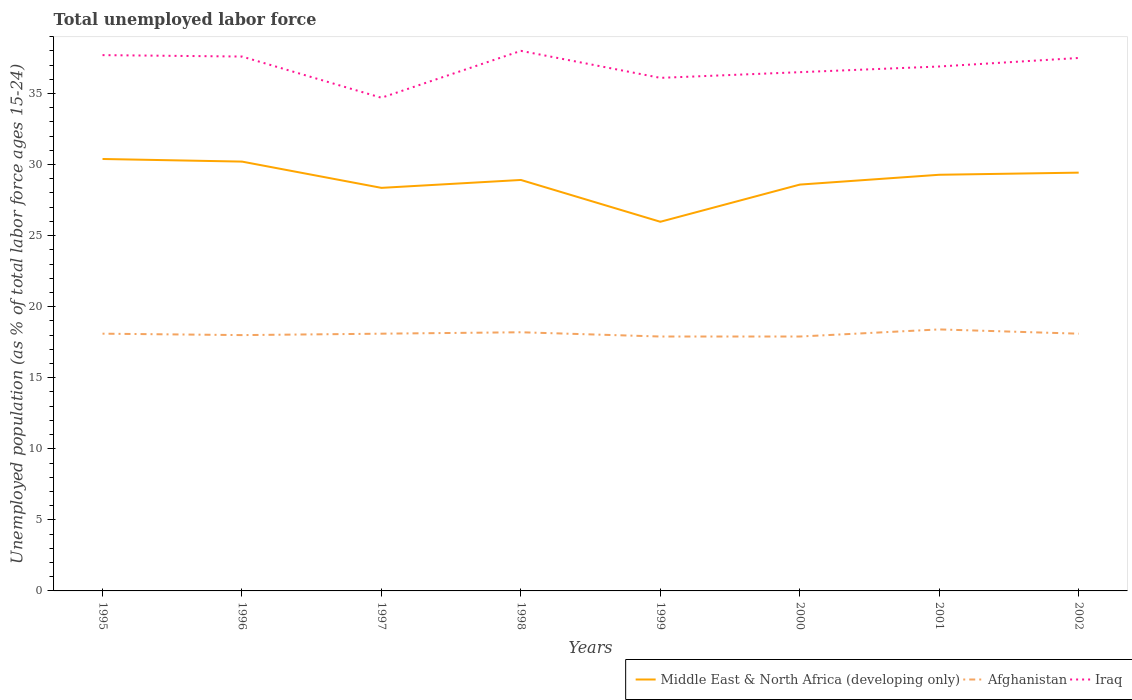Does the line corresponding to Afghanistan intersect with the line corresponding to Middle East & North Africa (developing only)?
Keep it short and to the point. No. Across all years, what is the maximum percentage of unemployed population in in Middle East & North Africa (developing only)?
Make the answer very short. 25.97. In which year was the percentage of unemployed population in in Middle East & North Africa (developing only) maximum?
Keep it short and to the point. 1999. What is the total percentage of unemployed population in in Afghanistan in the graph?
Your answer should be compact. -0.2. What is the difference between the highest and the second highest percentage of unemployed population in in Iraq?
Make the answer very short. 3.3. What is the difference between two consecutive major ticks on the Y-axis?
Ensure brevity in your answer.  5. Are the values on the major ticks of Y-axis written in scientific E-notation?
Your response must be concise. No. Does the graph contain grids?
Make the answer very short. No. Where does the legend appear in the graph?
Your answer should be compact. Bottom right. How many legend labels are there?
Give a very brief answer. 3. How are the legend labels stacked?
Your answer should be very brief. Horizontal. What is the title of the graph?
Provide a short and direct response. Total unemployed labor force. Does "Benin" appear as one of the legend labels in the graph?
Your answer should be very brief. No. What is the label or title of the X-axis?
Your answer should be very brief. Years. What is the label or title of the Y-axis?
Give a very brief answer. Unemployed population (as % of total labor force ages 15-24). What is the Unemployed population (as % of total labor force ages 15-24) of Middle East & North Africa (developing only) in 1995?
Your answer should be compact. 30.39. What is the Unemployed population (as % of total labor force ages 15-24) of Afghanistan in 1995?
Ensure brevity in your answer.  18.1. What is the Unemployed population (as % of total labor force ages 15-24) in Iraq in 1995?
Ensure brevity in your answer.  37.7. What is the Unemployed population (as % of total labor force ages 15-24) of Middle East & North Africa (developing only) in 1996?
Your response must be concise. 30.21. What is the Unemployed population (as % of total labor force ages 15-24) in Afghanistan in 1996?
Provide a succinct answer. 18. What is the Unemployed population (as % of total labor force ages 15-24) of Iraq in 1996?
Keep it short and to the point. 37.6. What is the Unemployed population (as % of total labor force ages 15-24) of Middle East & North Africa (developing only) in 1997?
Your answer should be compact. 28.36. What is the Unemployed population (as % of total labor force ages 15-24) in Afghanistan in 1997?
Your response must be concise. 18.1. What is the Unemployed population (as % of total labor force ages 15-24) in Iraq in 1997?
Offer a very short reply. 34.7. What is the Unemployed population (as % of total labor force ages 15-24) in Middle East & North Africa (developing only) in 1998?
Offer a very short reply. 28.92. What is the Unemployed population (as % of total labor force ages 15-24) of Afghanistan in 1998?
Your answer should be very brief. 18.2. What is the Unemployed population (as % of total labor force ages 15-24) in Middle East & North Africa (developing only) in 1999?
Provide a succinct answer. 25.97. What is the Unemployed population (as % of total labor force ages 15-24) of Afghanistan in 1999?
Keep it short and to the point. 17.9. What is the Unemployed population (as % of total labor force ages 15-24) of Iraq in 1999?
Give a very brief answer. 36.1. What is the Unemployed population (as % of total labor force ages 15-24) of Middle East & North Africa (developing only) in 2000?
Make the answer very short. 28.59. What is the Unemployed population (as % of total labor force ages 15-24) of Afghanistan in 2000?
Your response must be concise. 17.9. What is the Unemployed population (as % of total labor force ages 15-24) of Iraq in 2000?
Provide a succinct answer. 36.5. What is the Unemployed population (as % of total labor force ages 15-24) of Middle East & North Africa (developing only) in 2001?
Ensure brevity in your answer.  29.28. What is the Unemployed population (as % of total labor force ages 15-24) of Afghanistan in 2001?
Offer a very short reply. 18.4. What is the Unemployed population (as % of total labor force ages 15-24) of Iraq in 2001?
Your response must be concise. 36.9. What is the Unemployed population (as % of total labor force ages 15-24) in Middle East & North Africa (developing only) in 2002?
Offer a very short reply. 29.43. What is the Unemployed population (as % of total labor force ages 15-24) of Afghanistan in 2002?
Give a very brief answer. 18.1. What is the Unemployed population (as % of total labor force ages 15-24) in Iraq in 2002?
Your answer should be very brief. 37.5. Across all years, what is the maximum Unemployed population (as % of total labor force ages 15-24) of Middle East & North Africa (developing only)?
Provide a succinct answer. 30.39. Across all years, what is the maximum Unemployed population (as % of total labor force ages 15-24) of Afghanistan?
Make the answer very short. 18.4. Across all years, what is the minimum Unemployed population (as % of total labor force ages 15-24) in Middle East & North Africa (developing only)?
Keep it short and to the point. 25.97. Across all years, what is the minimum Unemployed population (as % of total labor force ages 15-24) of Afghanistan?
Offer a terse response. 17.9. Across all years, what is the minimum Unemployed population (as % of total labor force ages 15-24) of Iraq?
Provide a succinct answer. 34.7. What is the total Unemployed population (as % of total labor force ages 15-24) of Middle East & North Africa (developing only) in the graph?
Ensure brevity in your answer.  231.15. What is the total Unemployed population (as % of total labor force ages 15-24) of Afghanistan in the graph?
Ensure brevity in your answer.  144.7. What is the total Unemployed population (as % of total labor force ages 15-24) in Iraq in the graph?
Make the answer very short. 295. What is the difference between the Unemployed population (as % of total labor force ages 15-24) of Middle East & North Africa (developing only) in 1995 and that in 1996?
Your answer should be compact. 0.18. What is the difference between the Unemployed population (as % of total labor force ages 15-24) of Iraq in 1995 and that in 1996?
Ensure brevity in your answer.  0.1. What is the difference between the Unemployed population (as % of total labor force ages 15-24) in Middle East & North Africa (developing only) in 1995 and that in 1997?
Provide a short and direct response. 2.03. What is the difference between the Unemployed population (as % of total labor force ages 15-24) in Afghanistan in 1995 and that in 1997?
Keep it short and to the point. 0. What is the difference between the Unemployed population (as % of total labor force ages 15-24) in Iraq in 1995 and that in 1997?
Offer a terse response. 3. What is the difference between the Unemployed population (as % of total labor force ages 15-24) in Middle East & North Africa (developing only) in 1995 and that in 1998?
Ensure brevity in your answer.  1.48. What is the difference between the Unemployed population (as % of total labor force ages 15-24) of Middle East & North Africa (developing only) in 1995 and that in 1999?
Offer a terse response. 4.42. What is the difference between the Unemployed population (as % of total labor force ages 15-24) of Iraq in 1995 and that in 1999?
Your answer should be very brief. 1.6. What is the difference between the Unemployed population (as % of total labor force ages 15-24) in Middle East & North Africa (developing only) in 1995 and that in 2000?
Your answer should be compact. 1.8. What is the difference between the Unemployed population (as % of total labor force ages 15-24) of Middle East & North Africa (developing only) in 1995 and that in 2001?
Keep it short and to the point. 1.11. What is the difference between the Unemployed population (as % of total labor force ages 15-24) of Middle East & North Africa (developing only) in 1995 and that in 2002?
Ensure brevity in your answer.  0.96. What is the difference between the Unemployed population (as % of total labor force ages 15-24) in Afghanistan in 1995 and that in 2002?
Provide a short and direct response. 0. What is the difference between the Unemployed population (as % of total labor force ages 15-24) in Iraq in 1995 and that in 2002?
Provide a short and direct response. 0.2. What is the difference between the Unemployed population (as % of total labor force ages 15-24) of Middle East & North Africa (developing only) in 1996 and that in 1997?
Your answer should be very brief. 1.85. What is the difference between the Unemployed population (as % of total labor force ages 15-24) of Iraq in 1996 and that in 1997?
Give a very brief answer. 2.9. What is the difference between the Unemployed population (as % of total labor force ages 15-24) in Middle East & North Africa (developing only) in 1996 and that in 1998?
Ensure brevity in your answer.  1.29. What is the difference between the Unemployed population (as % of total labor force ages 15-24) of Afghanistan in 1996 and that in 1998?
Offer a very short reply. -0.2. What is the difference between the Unemployed population (as % of total labor force ages 15-24) in Middle East & North Africa (developing only) in 1996 and that in 1999?
Offer a terse response. 4.23. What is the difference between the Unemployed population (as % of total labor force ages 15-24) in Afghanistan in 1996 and that in 1999?
Provide a short and direct response. 0.1. What is the difference between the Unemployed population (as % of total labor force ages 15-24) of Iraq in 1996 and that in 1999?
Offer a terse response. 1.5. What is the difference between the Unemployed population (as % of total labor force ages 15-24) in Middle East & North Africa (developing only) in 1996 and that in 2000?
Provide a succinct answer. 1.62. What is the difference between the Unemployed population (as % of total labor force ages 15-24) of Afghanistan in 1996 and that in 2000?
Keep it short and to the point. 0.1. What is the difference between the Unemployed population (as % of total labor force ages 15-24) in Iraq in 1996 and that in 2000?
Provide a succinct answer. 1.1. What is the difference between the Unemployed population (as % of total labor force ages 15-24) in Middle East & North Africa (developing only) in 1996 and that in 2001?
Make the answer very short. 0.93. What is the difference between the Unemployed population (as % of total labor force ages 15-24) in Afghanistan in 1996 and that in 2001?
Your answer should be compact. -0.4. What is the difference between the Unemployed population (as % of total labor force ages 15-24) of Iraq in 1996 and that in 2001?
Your response must be concise. 0.7. What is the difference between the Unemployed population (as % of total labor force ages 15-24) in Middle East & North Africa (developing only) in 1996 and that in 2002?
Your response must be concise. 0.78. What is the difference between the Unemployed population (as % of total labor force ages 15-24) of Iraq in 1996 and that in 2002?
Provide a short and direct response. 0.1. What is the difference between the Unemployed population (as % of total labor force ages 15-24) of Middle East & North Africa (developing only) in 1997 and that in 1998?
Your answer should be very brief. -0.56. What is the difference between the Unemployed population (as % of total labor force ages 15-24) in Afghanistan in 1997 and that in 1998?
Offer a very short reply. -0.1. What is the difference between the Unemployed population (as % of total labor force ages 15-24) in Middle East & North Africa (developing only) in 1997 and that in 1999?
Keep it short and to the point. 2.39. What is the difference between the Unemployed population (as % of total labor force ages 15-24) of Iraq in 1997 and that in 1999?
Your answer should be compact. -1.4. What is the difference between the Unemployed population (as % of total labor force ages 15-24) in Middle East & North Africa (developing only) in 1997 and that in 2000?
Your answer should be compact. -0.23. What is the difference between the Unemployed population (as % of total labor force ages 15-24) of Afghanistan in 1997 and that in 2000?
Give a very brief answer. 0.2. What is the difference between the Unemployed population (as % of total labor force ages 15-24) of Iraq in 1997 and that in 2000?
Your answer should be compact. -1.8. What is the difference between the Unemployed population (as % of total labor force ages 15-24) of Middle East & North Africa (developing only) in 1997 and that in 2001?
Your answer should be very brief. -0.92. What is the difference between the Unemployed population (as % of total labor force ages 15-24) of Iraq in 1997 and that in 2001?
Give a very brief answer. -2.2. What is the difference between the Unemployed population (as % of total labor force ages 15-24) in Middle East & North Africa (developing only) in 1997 and that in 2002?
Your response must be concise. -1.07. What is the difference between the Unemployed population (as % of total labor force ages 15-24) in Afghanistan in 1997 and that in 2002?
Provide a short and direct response. 0. What is the difference between the Unemployed population (as % of total labor force ages 15-24) in Iraq in 1997 and that in 2002?
Make the answer very short. -2.8. What is the difference between the Unemployed population (as % of total labor force ages 15-24) in Middle East & North Africa (developing only) in 1998 and that in 1999?
Your response must be concise. 2.94. What is the difference between the Unemployed population (as % of total labor force ages 15-24) of Afghanistan in 1998 and that in 1999?
Your answer should be very brief. 0.3. What is the difference between the Unemployed population (as % of total labor force ages 15-24) in Middle East & North Africa (developing only) in 1998 and that in 2000?
Provide a succinct answer. 0.33. What is the difference between the Unemployed population (as % of total labor force ages 15-24) in Afghanistan in 1998 and that in 2000?
Your answer should be compact. 0.3. What is the difference between the Unemployed population (as % of total labor force ages 15-24) of Iraq in 1998 and that in 2000?
Offer a very short reply. 1.5. What is the difference between the Unemployed population (as % of total labor force ages 15-24) of Middle East & North Africa (developing only) in 1998 and that in 2001?
Your answer should be compact. -0.37. What is the difference between the Unemployed population (as % of total labor force ages 15-24) of Afghanistan in 1998 and that in 2001?
Your answer should be very brief. -0.2. What is the difference between the Unemployed population (as % of total labor force ages 15-24) of Iraq in 1998 and that in 2001?
Offer a terse response. 1.1. What is the difference between the Unemployed population (as % of total labor force ages 15-24) of Middle East & North Africa (developing only) in 1998 and that in 2002?
Offer a very short reply. -0.51. What is the difference between the Unemployed population (as % of total labor force ages 15-24) of Iraq in 1998 and that in 2002?
Keep it short and to the point. 0.5. What is the difference between the Unemployed population (as % of total labor force ages 15-24) in Middle East & North Africa (developing only) in 1999 and that in 2000?
Provide a short and direct response. -2.62. What is the difference between the Unemployed population (as % of total labor force ages 15-24) in Middle East & North Africa (developing only) in 1999 and that in 2001?
Ensure brevity in your answer.  -3.31. What is the difference between the Unemployed population (as % of total labor force ages 15-24) of Afghanistan in 1999 and that in 2001?
Ensure brevity in your answer.  -0.5. What is the difference between the Unemployed population (as % of total labor force ages 15-24) in Middle East & North Africa (developing only) in 1999 and that in 2002?
Your answer should be compact. -3.46. What is the difference between the Unemployed population (as % of total labor force ages 15-24) of Afghanistan in 1999 and that in 2002?
Give a very brief answer. -0.2. What is the difference between the Unemployed population (as % of total labor force ages 15-24) in Middle East & North Africa (developing only) in 2000 and that in 2001?
Offer a very short reply. -0.69. What is the difference between the Unemployed population (as % of total labor force ages 15-24) in Afghanistan in 2000 and that in 2001?
Your response must be concise. -0.5. What is the difference between the Unemployed population (as % of total labor force ages 15-24) in Iraq in 2000 and that in 2001?
Your response must be concise. -0.4. What is the difference between the Unemployed population (as % of total labor force ages 15-24) in Middle East & North Africa (developing only) in 2000 and that in 2002?
Ensure brevity in your answer.  -0.84. What is the difference between the Unemployed population (as % of total labor force ages 15-24) of Iraq in 2000 and that in 2002?
Provide a short and direct response. -1. What is the difference between the Unemployed population (as % of total labor force ages 15-24) of Middle East & North Africa (developing only) in 2001 and that in 2002?
Offer a terse response. -0.15. What is the difference between the Unemployed population (as % of total labor force ages 15-24) of Middle East & North Africa (developing only) in 1995 and the Unemployed population (as % of total labor force ages 15-24) of Afghanistan in 1996?
Provide a succinct answer. 12.39. What is the difference between the Unemployed population (as % of total labor force ages 15-24) of Middle East & North Africa (developing only) in 1995 and the Unemployed population (as % of total labor force ages 15-24) of Iraq in 1996?
Your answer should be compact. -7.21. What is the difference between the Unemployed population (as % of total labor force ages 15-24) of Afghanistan in 1995 and the Unemployed population (as % of total labor force ages 15-24) of Iraq in 1996?
Make the answer very short. -19.5. What is the difference between the Unemployed population (as % of total labor force ages 15-24) of Middle East & North Africa (developing only) in 1995 and the Unemployed population (as % of total labor force ages 15-24) of Afghanistan in 1997?
Ensure brevity in your answer.  12.29. What is the difference between the Unemployed population (as % of total labor force ages 15-24) in Middle East & North Africa (developing only) in 1995 and the Unemployed population (as % of total labor force ages 15-24) in Iraq in 1997?
Give a very brief answer. -4.31. What is the difference between the Unemployed population (as % of total labor force ages 15-24) of Afghanistan in 1995 and the Unemployed population (as % of total labor force ages 15-24) of Iraq in 1997?
Make the answer very short. -16.6. What is the difference between the Unemployed population (as % of total labor force ages 15-24) of Middle East & North Africa (developing only) in 1995 and the Unemployed population (as % of total labor force ages 15-24) of Afghanistan in 1998?
Offer a very short reply. 12.19. What is the difference between the Unemployed population (as % of total labor force ages 15-24) of Middle East & North Africa (developing only) in 1995 and the Unemployed population (as % of total labor force ages 15-24) of Iraq in 1998?
Give a very brief answer. -7.61. What is the difference between the Unemployed population (as % of total labor force ages 15-24) of Afghanistan in 1995 and the Unemployed population (as % of total labor force ages 15-24) of Iraq in 1998?
Give a very brief answer. -19.9. What is the difference between the Unemployed population (as % of total labor force ages 15-24) of Middle East & North Africa (developing only) in 1995 and the Unemployed population (as % of total labor force ages 15-24) of Afghanistan in 1999?
Provide a short and direct response. 12.49. What is the difference between the Unemployed population (as % of total labor force ages 15-24) of Middle East & North Africa (developing only) in 1995 and the Unemployed population (as % of total labor force ages 15-24) of Iraq in 1999?
Give a very brief answer. -5.71. What is the difference between the Unemployed population (as % of total labor force ages 15-24) of Afghanistan in 1995 and the Unemployed population (as % of total labor force ages 15-24) of Iraq in 1999?
Provide a succinct answer. -18. What is the difference between the Unemployed population (as % of total labor force ages 15-24) of Middle East & North Africa (developing only) in 1995 and the Unemployed population (as % of total labor force ages 15-24) of Afghanistan in 2000?
Keep it short and to the point. 12.49. What is the difference between the Unemployed population (as % of total labor force ages 15-24) of Middle East & North Africa (developing only) in 1995 and the Unemployed population (as % of total labor force ages 15-24) of Iraq in 2000?
Your answer should be compact. -6.11. What is the difference between the Unemployed population (as % of total labor force ages 15-24) in Afghanistan in 1995 and the Unemployed population (as % of total labor force ages 15-24) in Iraq in 2000?
Ensure brevity in your answer.  -18.4. What is the difference between the Unemployed population (as % of total labor force ages 15-24) in Middle East & North Africa (developing only) in 1995 and the Unemployed population (as % of total labor force ages 15-24) in Afghanistan in 2001?
Keep it short and to the point. 11.99. What is the difference between the Unemployed population (as % of total labor force ages 15-24) of Middle East & North Africa (developing only) in 1995 and the Unemployed population (as % of total labor force ages 15-24) of Iraq in 2001?
Make the answer very short. -6.51. What is the difference between the Unemployed population (as % of total labor force ages 15-24) in Afghanistan in 1995 and the Unemployed population (as % of total labor force ages 15-24) in Iraq in 2001?
Keep it short and to the point. -18.8. What is the difference between the Unemployed population (as % of total labor force ages 15-24) in Middle East & North Africa (developing only) in 1995 and the Unemployed population (as % of total labor force ages 15-24) in Afghanistan in 2002?
Give a very brief answer. 12.29. What is the difference between the Unemployed population (as % of total labor force ages 15-24) in Middle East & North Africa (developing only) in 1995 and the Unemployed population (as % of total labor force ages 15-24) in Iraq in 2002?
Give a very brief answer. -7.11. What is the difference between the Unemployed population (as % of total labor force ages 15-24) of Afghanistan in 1995 and the Unemployed population (as % of total labor force ages 15-24) of Iraq in 2002?
Offer a very short reply. -19.4. What is the difference between the Unemployed population (as % of total labor force ages 15-24) in Middle East & North Africa (developing only) in 1996 and the Unemployed population (as % of total labor force ages 15-24) in Afghanistan in 1997?
Keep it short and to the point. 12.11. What is the difference between the Unemployed population (as % of total labor force ages 15-24) of Middle East & North Africa (developing only) in 1996 and the Unemployed population (as % of total labor force ages 15-24) of Iraq in 1997?
Your answer should be very brief. -4.49. What is the difference between the Unemployed population (as % of total labor force ages 15-24) of Afghanistan in 1996 and the Unemployed population (as % of total labor force ages 15-24) of Iraq in 1997?
Provide a short and direct response. -16.7. What is the difference between the Unemployed population (as % of total labor force ages 15-24) of Middle East & North Africa (developing only) in 1996 and the Unemployed population (as % of total labor force ages 15-24) of Afghanistan in 1998?
Your response must be concise. 12.01. What is the difference between the Unemployed population (as % of total labor force ages 15-24) in Middle East & North Africa (developing only) in 1996 and the Unemployed population (as % of total labor force ages 15-24) in Iraq in 1998?
Ensure brevity in your answer.  -7.79. What is the difference between the Unemployed population (as % of total labor force ages 15-24) in Afghanistan in 1996 and the Unemployed population (as % of total labor force ages 15-24) in Iraq in 1998?
Make the answer very short. -20. What is the difference between the Unemployed population (as % of total labor force ages 15-24) of Middle East & North Africa (developing only) in 1996 and the Unemployed population (as % of total labor force ages 15-24) of Afghanistan in 1999?
Offer a terse response. 12.31. What is the difference between the Unemployed population (as % of total labor force ages 15-24) in Middle East & North Africa (developing only) in 1996 and the Unemployed population (as % of total labor force ages 15-24) in Iraq in 1999?
Ensure brevity in your answer.  -5.89. What is the difference between the Unemployed population (as % of total labor force ages 15-24) in Afghanistan in 1996 and the Unemployed population (as % of total labor force ages 15-24) in Iraq in 1999?
Keep it short and to the point. -18.1. What is the difference between the Unemployed population (as % of total labor force ages 15-24) of Middle East & North Africa (developing only) in 1996 and the Unemployed population (as % of total labor force ages 15-24) of Afghanistan in 2000?
Keep it short and to the point. 12.31. What is the difference between the Unemployed population (as % of total labor force ages 15-24) of Middle East & North Africa (developing only) in 1996 and the Unemployed population (as % of total labor force ages 15-24) of Iraq in 2000?
Make the answer very short. -6.29. What is the difference between the Unemployed population (as % of total labor force ages 15-24) of Afghanistan in 1996 and the Unemployed population (as % of total labor force ages 15-24) of Iraq in 2000?
Your answer should be very brief. -18.5. What is the difference between the Unemployed population (as % of total labor force ages 15-24) of Middle East & North Africa (developing only) in 1996 and the Unemployed population (as % of total labor force ages 15-24) of Afghanistan in 2001?
Provide a succinct answer. 11.81. What is the difference between the Unemployed population (as % of total labor force ages 15-24) of Middle East & North Africa (developing only) in 1996 and the Unemployed population (as % of total labor force ages 15-24) of Iraq in 2001?
Ensure brevity in your answer.  -6.69. What is the difference between the Unemployed population (as % of total labor force ages 15-24) of Afghanistan in 1996 and the Unemployed population (as % of total labor force ages 15-24) of Iraq in 2001?
Your response must be concise. -18.9. What is the difference between the Unemployed population (as % of total labor force ages 15-24) of Middle East & North Africa (developing only) in 1996 and the Unemployed population (as % of total labor force ages 15-24) of Afghanistan in 2002?
Offer a terse response. 12.11. What is the difference between the Unemployed population (as % of total labor force ages 15-24) in Middle East & North Africa (developing only) in 1996 and the Unemployed population (as % of total labor force ages 15-24) in Iraq in 2002?
Provide a short and direct response. -7.29. What is the difference between the Unemployed population (as % of total labor force ages 15-24) in Afghanistan in 1996 and the Unemployed population (as % of total labor force ages 15-24) in Iraq in 2002?
Make the answer very short. -19.5. What is the difference between the Unemployed population (as % of total labor force ages 15-24) of Middle East & North Africa (developing only) in 1997 and the Unemployed population (as % of total labor force ages 15-24) of Afghanistan in 1998?
Offer a terse response. 10.16. What is the difference between the Unemployed population (as % of total labor force ages 15-24) in Middle East & North Africa (developing only) in 1997 and the Unemployed population (as % of total labor force ages 15-24) in Iraq in 1998?
Your response must be concise. -9.64. What is the difference between the Unemployed population (as % of total labor force ages 15-24) of Afghanistan in 1997 and the Unemployed population (as % of total labor force ages 15-24) of Iraq in 1998?
Offer a very short reply. -19.9. What is the difference between the Unemployed population (as % of total labor force ages 15-24) of Middle East & North Africa (developing only) in 1997 and the Unemployed population (as % of total labor force ages 15-24) of Afghanistan in 1999?
Your answer should be very brief. 10.46. What is the difference between the Unemployed population (as % of total labor force ages 15-24) in Middle East & North Africa (developing only) in 1997 and the Unemployed population (as % of total labor force ages 15-24) in Iraq in 1999?
Provide a succinct answer. -7.74. What is the difference between the Unemployed population (as % of total labor force ages 15-24) in Middle East & North Africa (developing only) in 1997 and the Unemployed population (as % of total labor force ages 15-24) in Afghanistan in 2000?
Your answer should be very brief. 10.46. What is the difference between the Unemployed population (as % of total labor force ages 15-24) of Middle East & North Africa (developing only) in 1997 and the Unemployed population (as % of total labor force ages 15-24) of Iraq in 2000?
Provide a short and direct response. -8.14. What is the difference between the Unemployed population (as % of total labor force ages 15-24) of Afghanistan in 1997 and the Unemployed population (as % of total labor force ages 15-24) of Iraq in 2000?
Keep it short and to the point. -18.4. What is the difference between the Unemployed population (as % of total labor force ages 15-24) in Middle East & North Africa (developing only) in 1997 and the Unemployed population (as % of total labor force ages 15-24) in Afghanistan in 2001?
Ensure brevity in your answer.  9.96. What is the difference between the Unemployed population (as % of total labor force ages 15-24) of Middle East & North Africa (developing only) in 1997 and the Unemployed population (as % of total labor force ages 15-24) of Iraq in 2001?
Give a very brief answer. -8.54. What is the difference between the Unemployed population (as % of total labor force ages 15-24) of Afghanistan in 1997 and the Unemployed population (as % of total labor force ages 15-24) of Iraq in 2001?
Give a very brief answer. -18.8. What is the difference between the Unemployed population (as % of total labor force ages 15-24) in Middle East & North Africa (developing only) in 1997 and the Unemployed population (as % of total labor force ages 15-24) in Afghanistan in 2002?
Offer a terse response. 10.26. What is the difference between the Unemployed population (as % of total labor force ages 15-24) in Middle East & North Africa (developing only) in 1997 and the Unemployed population (as % of total labor force ages 15-24) in Iraq in 2002?
Ensure brevity in your answer.  -9.14. What is the difference between the Unemployed population (as % of total labor force ages 15-24) in Afghanistan in 1997 and the Unemployed population (as % of total labor force ages 15-24) in Iraq in 2002?
Offer a very short reply. -19.4. What is the difference between the Unemployed population (as % of total labor force ages 15-24) of Middle East & North Africa (developing only) in 1998 and the Unemployed population (as % of total labor force ages 15-24) of Afghanistan in 1999?
Provide a succinct answer. 11.02. What is the difference between the Unemployed population (as % of total labor force ages 15-24) in Middle East & North Africa (developing only) in 1998 and the Unemployed population (as % of total labor force ages 15-24) in Iraq in 1999?
Offer a very short reply. -7.18. What is the difference between the Unemployed population (as % of total labor force ages 15-24) in Afghanistan in 1998 and the Unemployed population (as % of total labor force ages 15-24) in Iraq in 1999?
Offer a very short reply. -17.9. What is the difference between the Unemployed population (as % of total labor force ages 15-24) of Middle East & North Africa (developing only) in 1998 and the Unemployed population (as % of total labor force ages 15-24) of Afghanistan in 2000?
Provide a short and direct response. 11.02. What is the difference between the Unemployed population (as % of total labor force ages 15-24) in Middle East & North Africa (developing only) in 1998 and the Unemployed population (as % of total labor force ages 15-24) in Iraq in 2000?
Keep it short and to the point. -7.58. What is the difference between the Unemployed population (as % of total labor force ages 15-24) of Afghanistan in 1998 and the Unemployed population (as % of total labor force ages 15-24) of Iraq in 2000?
Keep it short and to the point. -18.3. What is the difference between the Unemployed population (as % of total labor force ages 15-24) in Middle East & North Africa (developing only) in 1998 and the Unemployed population (as % of total labor force ages 15-24) in Afghanistan in 2001?
Provide a short and direct response. 10.52. What is the difference between the Unemployed population (as % of total labor force ages 15-24) in Middle East & North Africa (developing only) in 1998 and the Unemployed population (as % of total labor force ages 15-24) in Iraq in 2001?
Keep it short and to the point. -7.98. What is the difference between the Unemployed population (as % of total labor force ages 15-24) in Afghanistan in 1998 and the Unemployed population (as % of total labor force ages 15-24) in Iraq in 2001?
Offer a terse response. -18.7. What is the difference between the Unemployed population (as % of total labor force ages 15-24) in Middle East & North Africa (developing only) in 1998 and the Unemployed population (as % of total labor force ages 15-24) in Afghanistan in 2002?
Offer a very short reply. 10.82. What is the difference between the Unemployed population (as % of total labor force ages 15-24) in Middle East & North Africa (developing only) in 1998 and the Unemployed population (as % of total labor force ages 15-24) in Iraq in 2002?
Give a very brief answer. -8.58. What is the difference between the Unemployed population (as % of total labor force ages 15-24) of Afghanistan in 1998 and the Unemployed population (as % of total labor force ages 15-24) of Iraq in 2002?
Provide a short and direct response. -19.3. What is the difference between the Unemployed population (as % of total labor force ages 15-24) in Middle East & North Africa (developing only) in 1999 and the Unemployed population (as % of total labor force ages 15-24) in Afghanistan in 2000?
Keep it short and to the point. 8.07. What is the difference between the Unemployed population (as % of total labor force ages 15-24) of Middle East & North Africa (developing only) in 1999 and the Unemployed population (as % of total labor force ages 15-24) of Iraq in 2000?
Offer a terse response. -10.53. What is the difference between the Unemployed population (as % of total labor force ages 15-24) of Afghanistan in 1999 and the Unemployed population (as % of total labor force ages 15-24) of Iraq in 2000?
Ensure brevity in your answer.  -18.6. What is the difference between the Unemployed population (as % of total labor force ages 15-24) of Middle East & North Africa (developing only) in 1999 and the Unemployed population (as % of total labor force ages 15-24) of Afghanistan in 2001?
Give a very brief answer. 7.57. What is the difference between the Unemployed population (as % of total labor force ages 15-24) in Middle East & North Africa (developing only) in 1999 and the Unemployed population (as % of total labor force ages 15-24) in Iraq in 2001?
Provide a succinct answer. -10.93. What is the difference between the Unemployed population (as % of total labor force ages 15-24) of Afghanistan in 1999 and the Unemployed population (as % of total labor force ages 15-24) of Iraq in 2001?
Make the answer very short. -19. What is the difference between the Unemployed population (as % of total labor force ages 15-24) of Middle East & North Africa (developing only) in 1999 and the Unemployed population (as % of total labor force ages 15-24) of Afghanistan in 2002?
Keep it short and to the point. 7.87. What is the difference between the Unemployed population (as % of total labor force ages 15-24) of Middle East & North Africa (developing only) in 1999 and the Unemployed population (as % of total labor force ages 15-24) of Iraq in 2002?
Give a very brief answer. -11.53. What is the difference between the Unemployed population (as % of total labor force ages 15-24) of Afghanistan in 1999 and the Unemployed population (as % of total labor force ages 15-24) of Iraq in 2002?
Your response must be concise. -19.6. What is the difference between the Unemployed population (as % of total labor force ages 15-24) of Middle East & North Africa (developing only) in 2000 and the Unemployed population (as % of total labor force ages 15-24) of Afghanistan in 2001?
Your answer should be very brief. 10.19. What is the difference between the Unemployed population (as % of total labor force ages 15-24) of Middle East & North Africa (developing only) in 2000 and the Unemployed population (as % of total labor force ages 15-24) of Iraq in 2001?
Offer a very short reply. -8.31. What is the difference between the Unemployed population (as % of total labor force ages 15-24) of Middle East & North Africa (developing only) in 2000 and the Unemployed population (as % of total labor force ages 15-24) of Afghanistan in 2002?
Your response must be concise. 10.49. What is the difference between the Unemployed population (as % of total labor force ages 15-24) of Middle East & North Africa (developing only) in 2000 and the Unemployed population (as % of total labor force ages 15-24) of Iraq in 2002?
Make the answer very short. -8.91. What is the difference between the Unemployed population (as % of total labor force ages 15-24) in Afghanistan in 2000 and the Unemployed population (as % of total labor force ages 15-24) in Iraq in 2002?
Provide a succinct answer. -19.6. What is the difference between the Unemployed population (as % of total labor force ages 15-24) in Middle East & North Africa (developing only) in 2001 and the Unemployed population (as % of total labor force ages 15-24) in Afghanistan in 2002?
Your response must be concise. 11.18. What is the difference between the Unemployed population (as % of total labor force ages 15-24) of Middle East & North Africa (developing only) in 2001 and the Unemployed population (as % of total labor force ages 15-24) of Iraq in 2002?
Provide a succinct answer. -8.22. What is the difference between the Unemployed population (as % of total labor force ages 15-24) in Afghanistan in 2001 and the Unemployed population (as % of total labor force ages 15-24) in Iraq in 2002?
Make the answer very short. -19.1. What is the average Unemployed population (as % of total labor force ages 15-24) of Middle East & North Africa (developing only) per year?
Your answer should be very brief. 28.89. What is the average Unemployed population (as % of total labor force ages 15-24) in Afghanistan per year?
Give a very brief answer. 18.09. What is the average Unemployed population (as % of total labor force ages 15-24) of Iraq per year?
Offer a very short reply. 36.88. In the year 1995, what is the difference between the Unemployed population (as % of total labor force ages 15-24) of Middle East & North Africa (developing only) and Unemployed population (as % of total labor force ages 15-24) of Afghanistan?
Give a very brief answer. 12.29. In the year 1995, what is the difference between the Unemployed population (as % of total labor force ages 15-24) of Middle East & North Africa (developing only) and Unemployed population (as % of total labor force ages 15-24) of Iraq?
Your answer should be compact. -7.31. In the year 1995, what is the difference between the Unemployed population (as % of total labor force ages 15-24) of Afghanistan and Unemployed population (as % of total labor force ages 15-24) of Iraq?
Your response must be concise. -19.6. In the year 1996, what is the difference between the Unemployed population (as % of total labor force ages 15-24) of Middle East & North Africa (developing only) and Unemployed population (as % of total labor force ages 15-24) of Afghanistan?
Provide a short and direct response. 12.21. In the year 1996, what is the difference between the Unemployed population (as % of total labor force ages 15-24) in Middle East & North Africa (developing only) and Unemployed population (as % of total labor force ages 15-24) in Iraq?
Offer a terse response. -7.39. In the year 1996, what is the difference between the Unemployed population (as % of total labor force ages 15-24) of Afghanistan and Unemployed population (as % of total labor force ages 15-24) of Iraq?
Ensure brevity in your answer.  -19.6. In the year 1997, what is the difference between the Unemployed population (as % of total labor force ages 15-24) in Middle East & North Africa (developing only) and Unemployed population (as % of total labor force ages 15-24) in Afghanistan?
Ensure brevity in your answer.  10.26. In the year 1997, what is the difference between the Unemployed population (as % of total labor force ages 15-24) of Middle East & North Africa (developing only) and Unemployed population (as % of total labor force ages 15-24) of Iraq?
Provide a short and direct response. -6.34. In the year 1997, what is the difference between the Unemployed population (as % of total labor force ages 15-24) in Afghanistan and Unemployed population (as % of total labor force ages 15-24) in Iraq?
Keep it short and to the point. -16.6. In the year 1998, what is the difference between the Unemployed population (as % of total labor force ages 15-24) of Middle East & North Africa (developing only) and Unemployed population (as % of total labor force ages 15-24) of Afghanistan?
Your answer should be compact. 10.72. In the year 1998, what is the difference between the Unemployed population (as % of total labor force ages 15-24) in Middle East & North Africa (developing only) and Unemployed population (as % of total labor force ages 15-24) in Iraq?
Provide a short and direct response. -9.08. In the year 1998, what is the difference between the Unemployed population (as % of total labor force ages 15-24) in Afghanistan and Unemployed population (as % of total labor force ages 15-24) in Iraq?
Offer a very short reply. -19.8. In the year 1999, what is the difference between the Unemployed population (as % of total labor force ages 15-24) of Middle East & North Africa (developing only) and Unemployed population (as % of total labor force ages 15-24) of Afghanistan?
Offer a terse response. 8.07. In the year 1999, what is the difference between the Unemployed population (as % of total labor force ages 15-24) of Middle East & North Africa (developing only) and Unemployed population (as % of total labor force ages 15-24) of Iraq?
Keep it short and to the point. -10.13. In the year 1999, what is the difference between the Unemployed population (as % of total labor force ages 15-24) of Afghanistan and Unemployed population (as % of total labor force ages 15-24) of Iraq?
Offer a terse response. -18.2. In the year 2000, what is the difference between the Unemployed population (as % of total labor force ages 15-24) of Middle East & North Africa (developing only) and Unemployed population (as % of total labor force ages 15-24) of Afghanistan?
Make the answer very short. 10.69. In the year 2000, what is the difference between the Unemployed population (as % of total labor force ages 15-24) of Middle East & North Africa (developing only) and Unemployed population (as % of total labor force ages 15-24) of Iraq?
Offer a terse response. -7.91. In the year 2000, what is the difference between the Unemployed population (as % of total labor force ages 15-24) in Afghanistan and Unemployed population (as % of total labor force ages 15-24) in Iraq?
Offer a very short reply. -18.6. In the year 2001, what is the difference between the Unemployed population (as % of total labor force ages 15-24) of Middle East & North Africa (developing only) and Unemployed population (as % of total labor force ages 15-24) of Afghanistan?
Make the answer very short. 10.88. In the year 2001, what is the difference between the Unemployed population (as % of total labor force ages 15-24) in Middle East & North Africa (developing only) and Unemployed population (as % of total labor force ages 15-24) in Iraq?
Your answer should be very brief. -7.62. In the year 2001, what is the difference between the Unemployed population (as % of total labor force ages 15-24) in Afghanistan and Unemployed population (as % of total labor force ages 15-24) in Iraq?
Ensure brevity in your answer.  -18.5. In the year 2002, what is the difference between the Unemployed population (as % of total labor force ages 15-24) of Middle East & North Africa (developing only) and Unemployed population (as % of total labor force ages 15-24) of Afghanistan?
Provide a short and direct response. 11.33. In the year 2002, what is the difference between the Unemployed population (as % of total labor force ages 15-24) of Middle East & North Africa (developing only) and Unemployed population (as % of total labor force ages 15-24) of Iraq?
Provide a succinct answer. -8.07. In the year 2002, what is the difference between the Unemployed population (as % of total labor force ages 15-24) of Afghanistan and Unemployed population (as % of total labor force ages 15-24) of Iraq?
Your answer should be compact. -19.4. What is the ratio of the Unemployed population (as % of total labor force ages 15-24) in Afghanistan in 1995 to that in 1996?
Your answer should be very brief. 1.01. What is the ratio of the Unemployed population (as % of total labor force ages 15-24) of Middle East & North Africa (developing only) in 1995 to that in 1997?
Your answer should be compact. 1.07. What is the ratio of the Unemployed population (as % of total labor force ages 15-24) of Afghanistan in 1995 to that in 1997?
Provide a succinct answer. 1. What is the ratio of the Unemployed population (as % of total labor force ages 15-24) in Iraq in 1995 to that in 1997?
Provide a succinct answer. 1.09. What is the ratio of the Unemployed population (as % of total labor force ages 15-24) of Middle East & North Africa (developing only) in 1995 to that in 1998?
Make the answer very short. 1.05. What is the ratio of the Unemployed population (as % of total labor force ages 15-24) in Middle East & North Africa (developing only) in 1995 to that in 1999?
Your response must be concise. 1.17. What is the ratio of the Unemployed population (as % of total labor force ages 15-24) of Afghanistan in 1995 to that in 1999?
Keep it short and to the point. 1.01. What is the ratio of the Unemployed population (as % of total labor force ages 15-24) in Iraq in 1995 to that in 1999?
Your answer should be compact. 1.04. What is the ratio of the Unemployed population (as % of total labor force ages 15-24) in Middle East & North Africa (developing only) in 1995 to that in 2000?
Offer a terse response. 1.06. What is the ratio of the Unemployed population (as % of total labor force ages 15-24) of Afghanistan in 1995 to that in 2000?
Provide a short and direct response. 1.01. What is the ratio of the Unemployed population (as % of total labor force ages 15-24) in Iraq in 1995 to that in 2000?
Give a very brief answer. 1.03. What is the ratio of the Unemployed population (as % of total labor force ages 15-24) of Middle East & North Africa (developing only) in 1995 to that in 2001?
Provide a succinct answer. 1.04. What is the ratio of the Unemployed population (as % of total labor force ages 15-24) in Afghanistan in 1995 to that in 2001?
Your response must be concise. 0.98. What is the ratio of the Unemployed population (as % of total labor force ages 15-24) in Iraq in 1995 to that in 2001?
Give a very brief answer. 1.02. What is the ratio of the Unemployed population (as % of total labor force ages 15-24) of Middle East & North Africa (developing only) in 1995 to that in 2002?
Your response must be concise. 1.03. What is the ratio of the Unemployed population (as % of total labor force ages 15-24) in Afghanistan in 1995 to that in 2002?
Ensure brevity in your answer.  1. What is the ratio of the Unemployed population (as % of total labor force ages 15-24) of Middle East & North Africa (developing only) in 1996 to that in 1997?
Your answer should be very brief. 1.07. What is the ratio of the Unemployed population (as % of total labor force ages 15-24) of Afghanistan in 1996 to that in 1997?
Your answer should be compact. 0.99. What is the ratio of the Unemployed population (as % of total labor force ages 15-24) in Iraq in 1996 to that in 1997?
Provide a short and direct response. 1.08. What is the ratio of the Unemployed population (as % of total labor force ages 15-24) in Middle East & North Africa (developing only) in 1996 to that in 1998?
Provide a short and direct response. 1.04. What is the ratio of the Unemployed population (as % of total labor force ages 15-24) of Iraq in 1996 to that in 1998?
Make the answer very short. 0.99. What is the ratio of the Unemployed population (as % of total labor force ages 15-24) in Middle East & North Africa (developing only) in 1996 to that in 1999?
Give a very brief answer. 1.16. What is the ratio of the Unemployed population (as % of total labor force ages 15-24) in Afghanistan in 1996 to that in 1999?
Offer a very short reply. 1.01. What is the ratio of the Unemployed population (as % of total labor force ages 15-24) in Iraq in 1996 to that in 1999?
Keep it short and to the point. 1.04. What is the ratio of the Unemployed population (as % of total labor force ages 15-24) of Middle East & North Africa (developing only) in 1996 to that in 2000?
Ensure brevity in your answer.  1.06. What is the ratio of the Unemployed population (as % of total labor force ages 15-24) of Afghanistan in 1996 to that in 2000?
Ensure brevity in your answer.  1.01. What is the ratio of the Unemployed population (as % of total labor force ages 15-24) of Iraq in 1996 to that in 2000?
Your response must be concise. 1.03. What is the ratio of the Unemployed population (as % of total labor force ages 15-24) in Middle East & North Africa (developing only) in 1996 to that in 2001?
Keep it short and to the point. 1.03. What is the ratio of the Unemployed population (as % of total labor force ages 15-24) in Afghanistan in 1996 to that in 2001?
Keep it short and to the point. 0.98. What is the ratio of the Unemployed population (as % of total labor force ages 15-24) in Iraq in 1996 to that in 2001?
Offer a terse response. 1.02. What is the ratio of the Unemployed population (as % of total labor force ages 15-24) of Middle East & North Africa (developing only) in 1996 to that in 2002?
Keep it short and to the point. 1.03. What is the ratio of the Unemployed population (as % of total labor force ages 15-24) in Afghanistan in 1996 to that in 2002?
Your answer should be compact. 0.99. What is the ratio of the Unemployed population (as % of total labor force ages 15-24) in Iraq in 1996 to that in 2002?
Ensure brevity in your answer.  1. What is the ratio of the Unemployed population (as % of total labor force ages 15-24) of Middle East & North Africa (developing only) in 1997 to that in 1998?
Keep it short and to the point. 0.98. What is the ratio of the Unemployed population (as % of total labor force ages 15-24) of Afghanistan in 1997 to that in 1998?
Provide a succinct answer. 0.99. What is the ratio of the Unemployed population (as % of total labor force ages 15-24) in Iraq in 1997 to that in 1998?
Keep it short and to the point. 0.91. What is the ratio of the Unemployed population (as % of total labor force ages 15-24) in Middle East & North Africa (developing only) in 1997 to that in 1999?
Provide a short and direct response. 1.09. What is the ratio of the Unemployed population (as % of total labor force ages 15-24) in Afghanistan in 1997 to that in 1999?
Provide a short and direct response. 1.01. What is the ratio of the Unemployed population (as % of total labor force ages 15-24) in Iraq in 1997 to that in 1999?
Offer a terse response. 0.96. What is the ratio of the Unemployed population (as % of total labor force ages 15-24) of Afghanistan in 1997 to that in 2000?
Provide a succinct answer. 1.01. What is the ratio of the Unemployed population (as % of total labor force ages 15-24) in Iraq in 1997 to that in 2000?
Offer a terse response. 0.95. What is the ratio of the Unemployed population (as % of total labor force ages 15-24) of Middle East & North Africa (developing only) in 1997 to that in 2001?
Provide a succinct answer. 0.97. What is the ratio of the Unemployed population (as % of total labor force ages 15-24) of Afghanistan in 1997 to that in 2001?
Offer a terse response. 0.98. What is the ratio of the Unemployed population (as % of total labor force ages 15-24) of Iraq in 1997 to that in 2001?
Offer a very short reply. 0.94. What is the ratio of the Unemployed population (as % of total labor force ages 15-24) in Middle East & North Africa (developing only) in 1997 to that in 2002?
Your answer should be very brief. 0.96. What is the ratio of the Unemployed population (as % of total labor force ages 15-24) in Iraq in 1997 to that in 2002?
Keep it short and to the point. 0.93. What is the ratio of the Unemployed population (as % of total labor force ages 15-24) in Middle East & North Africa (developing only) in 1998 to that in 1999?
Your answer should be very brief. 1.11. What is the ratio of the Unemployed population (as % of total labor force ages 15-24) in Afghanistan in 1998 to that in 1999?
Offer a very short reply. 1.02. What is the ratio of the Unemployed population (as % of total labor force ages 15-24) in Iraq in 1998 to that in 1999?
Your answer should be very brief. 1.05. What is the ratio of the Unemployed population (as % of total labor force ages 15-24) in Middle East & North Africa (developing only) in 1998 to that in 2000?
Ensure brevity in your answer.  1.01. What is the ratio of the Unemployed population (as % of total labor force ages 15-24) of Afghanistan in 1998 to that in 2000?
Offer a terse response. 1.02. What is the ratio of the Unemployed population (as % of total labor force ages 15-24) in Iraq in 1998 to that in 2000?
Ensure brevity in your answer.  1.04. What is the ratio of the Unemployed population (as % of total labor force ages 15-24) in Middle East & North Africa (developing only) in 1998 to that in 2001?
Give a very brief answer. 0.99. What is the ratio of the Unemployed population (as % of total labor force ages 15-24) of Iraq in 1998 to that in 2001?
Ensure brevity in your answer.  1.03. What is the ratio of the Unemployed population (as % of total labor force ages 15-24) in Middle East & North Africa (developing only) in 1998 to that in 2002?
Offer a very short reply. 0.98. What is the ratio of the Unemployed population (as % of total labor force ages 15-24) in Afghanistan in 1998 to that in 2002?
Keep it short and to the point. 1.01. What is the ratio of the Unemployed population (as % of total labor force ages 15-24) of Iraq in 1998 to that in 2002?
Provide a short and direct response. 1.01. What is the ratio of the Unemployed population (as % of total labor force ages 15-24) in Middle East & North Africa (developing only) in 1999 to that in 2000?
Provide a succinct answer. 0.91. What is the ratio of the Unemployed population (as % of total labor force ages 15-24) in Afghanistan in 1999 to that in 2000?
Offer a terse response. 1. What is the ratio of the Unemployed population (as % of total labor force ages 15-24) of Middle East & North Africa (developing only) in 1999 to that in 2001?
Make the answer very short. 0.89. What is the ratio of the Unemployed population (as % of total labor force ages 15-24) of Afghanistan in 1999 to that in 2001?
Your answer should be compact. 0.97. What is the ratio of the Unemployed population (as % of total labor force ages 15-24) of Iraq in 1999 to that in 2001?
Your response must be concise. 0.98. What is the ratio of the Unemployed population (as % of total labor force ages 15-24) in Middle East & North Africa (developing only) in 1999 to that in 2002?
Give a very brief answer. 0.88. What is the ratio of the Unemployed population (as % of total labor force ages 15-24) of Iraq in 1999 to that in 2002?
Provide a succinct answer. 0.96. What is the ratio of the Unemployed population (as % of total labor force ages 15-24) of Middle East & North Africa (developing only) in 2000 to that in 2001?
Provide a short and direct response. 0.98. What is the ratio of the Unemployed population (as % of total labor force ages 15-24) in Afghanistan in 2000 to that in 2001?
Your answer should be very brief. 0.97. What is the ratio of the Unemployed population (as % of total labor force ages 15-24) of Middle East & North Africa (developing only) in 2000 to that in 2002?
Provide a short and direct response. 0.97. What is the ratio of the Unemployed population (as % of total labor force ages 15-24) of Iraq in 2000 to that in 2002?
Your answer should be compact. 0.97. What is the ratio of the Unemployed population (as % of total labor force ages 15-24) of Middle East & North Africa (developing only) in 2001 to that in 2002?
Your response must be concise. 0.99. What is the ratio of the Unemployed population (as % of total labor force ages 15-24) in Afghanistan in 2001 to that in 2002?
Your answer should be compact. 1.02. What is the ratio of the Unemployed population (as % of total labor force ages 15-24) in Iraq in 2001 to that in 2002?
Provide a succinct answer. 0.98. What is the difference between the highest and the second highest Unemployed population (as % of total labor force ages 15-24) in Middle East & North Africa (developing only)?
Give a very brief answer. 0.18. What is the difference between the highest and the second highest Unemployed population (as % of total labor force ages 15-24) in Afghanistan?
Provide a short and direct response. 0.2. What is the difference between the highest and the second highest Unemployed population (as % of total labor force ages 15-24) of Iraq?
Make the answer very short. 0.3. What is the difference between the highest and the lowest Unemployed population (as % of total labor force ages 15-24) of Middle East & North Africa (developing only)?
Keep it short and to the point. 4.42. What is the difference between the highest and the lowest Unemployed population (as % of total labor force ages 15-24) of Afghanistan?
Offer a very short reply. 0.5. 